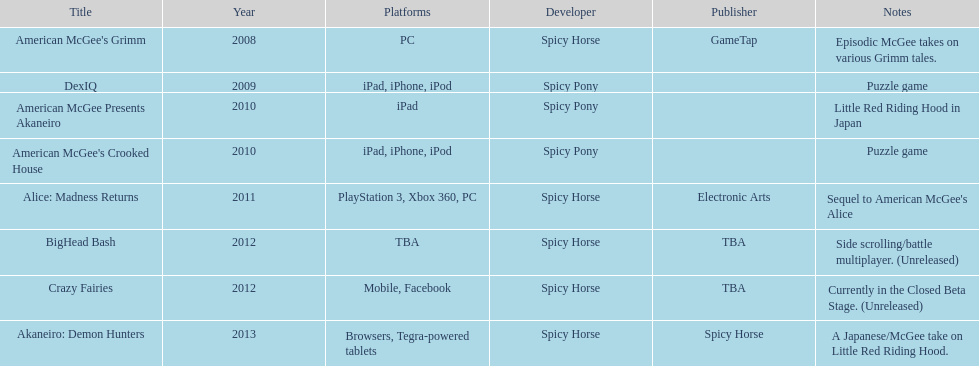What platform was used for the last title on this chart? Browsers, Tegra-powered tablets. 